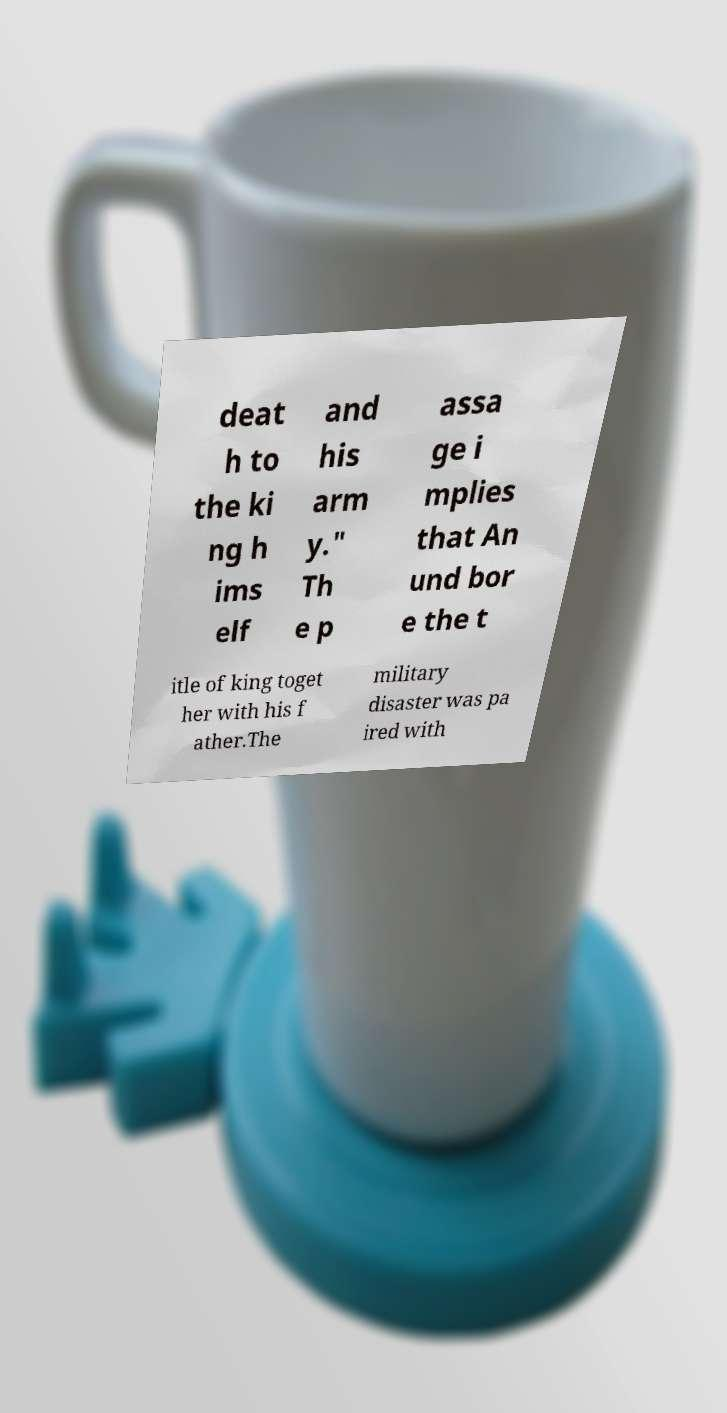Could you extract and type out the text from this image? deat h to the ki ng h ims elf and his arm y." Th e p assa ge i mplies that An und bor e the t itle of king toget her with his f ather.The military disaster was pa ired with 